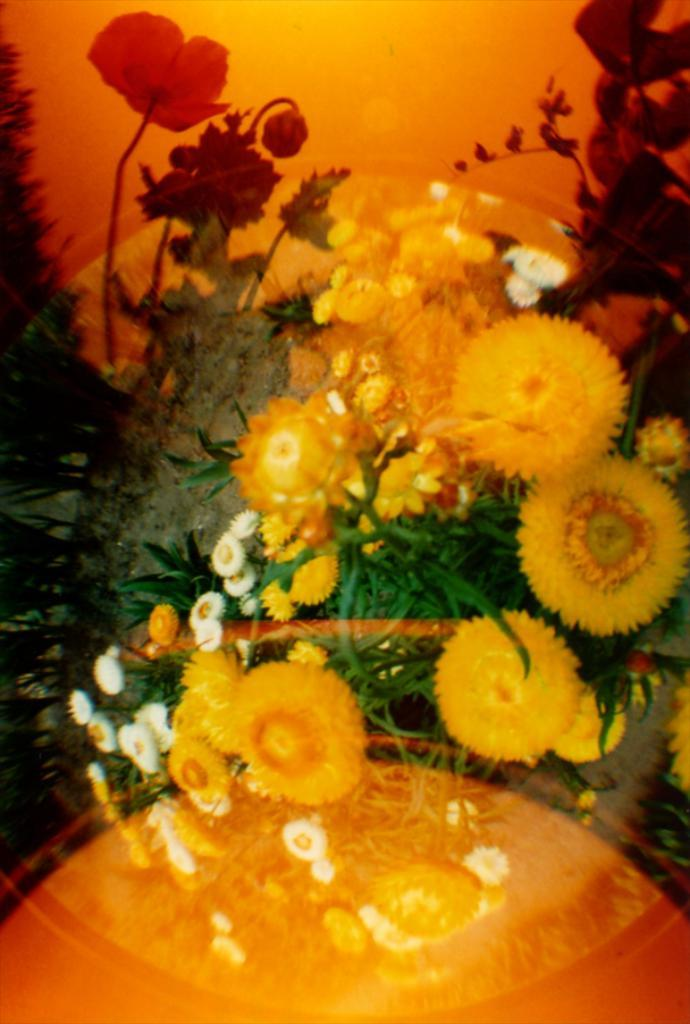What type of living organisms can be seen in the image? Flowers are visible in the image. What type of coal can be seen in the image? There is no coal present in the image; it features flowers. Is there a house visible in the image? There is no house present in the image; it only contains flowers. 